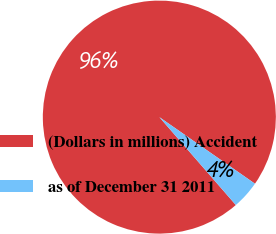Convert chart. <chart><loc_0><loc_0><loc_500><loc_500><pie_chart><fcel>(Dollars in millions) Accident<fcel>as of December 31 2011<nl><fcel>96.08%<fcel>3.92%<nl></chart> 